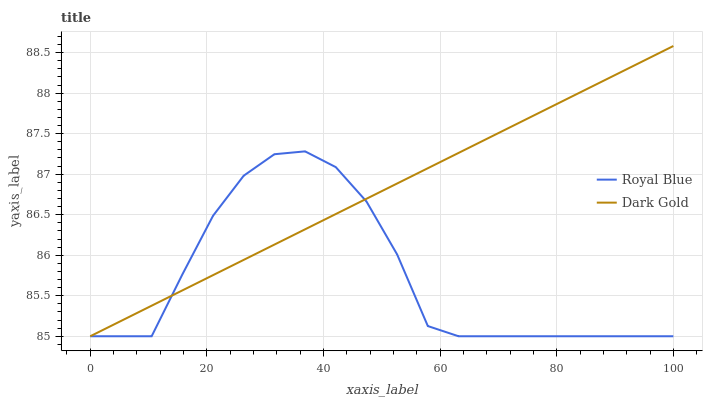Does Royal Blue have the minimum area under the curve?
Answer yes or no. Yes. Does Dark Gold have the maximum area under the curve?
Answer yes or no. Yes. Does Dark Gold have the minimum area under the curve?
Answer yes or no. No. Is Dark Gold the smoothest?
Answer yes or no. Yes. Is Royal Blue the roughest?
Answer yes or no. Yes. Is Dark Gold the roughest?
Answer yes or no. No. Does Royal Blue have the lowest value?
Answer yes or no. Yes. Does Dark Gold have the highest value?
Answer yes or no. Yes. Does Dark Gold intersect Royal Blue?
Answer yes or no. Yes. Is Dark Gold less than Royal Blue?
Answer yes or no. No. Is Dark Gold greater than Royal Blue?
Answer yes or no. No. 